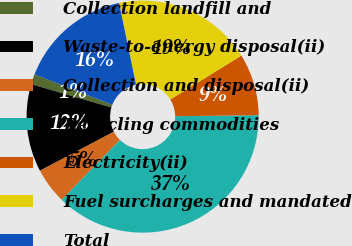<chart> <loc_0><loc_0><loc_500><loc_500><pie_chart><fcel>Collection landfill and<fcel>Waste-to-energy disposal(ii)<fcel>Collection and disposal(ii)<fcel>Recycling commodities<fcel>Electricity(ii)<fcel>Fuel surcharges and mandated<fcel>Total<nl><fcel>1.41%<fcel>12.23%<fcel>5.01%<fcel>37.46%<fcel>8.62%<fcel>19.44%<fcel>15.83%<nl></chart> 